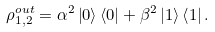Convert formula to latex. <formula><loc_0><loc_0><loc_500><loc_500>\rho _ { 1 , 2 } ^ { o u t } = \alpha ^ { 2 } \left | { 0 } \right \rangle \left \langle { 0 } \right | + \beta ^ { 2 } \left | { 1 } \right \rangle \left \langle { 1 } \right | .</formula> 